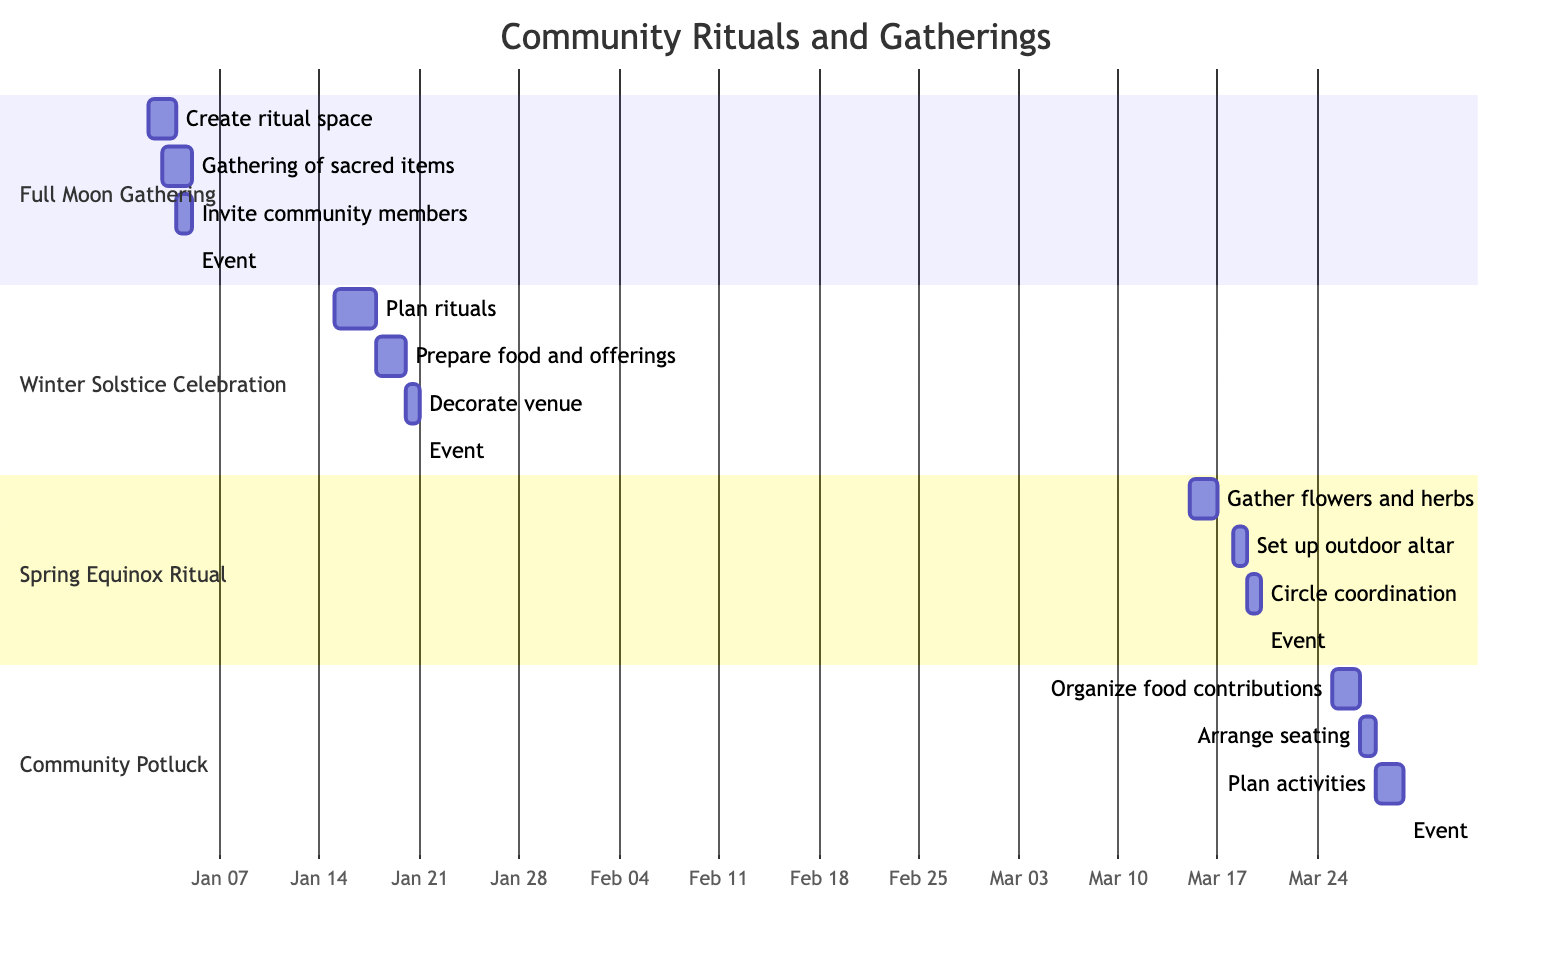What is the date of the Full Moon Gathering? The Gantt chart lists the Full Moon Gathering under the section title, and the associated date next to it is January 5, 2024.
Answer: January 5, 2024 What are the themes for the Winter Solstice Celebration? The Gantt chart specifies the theme for each event in the description, and for the Winter Solstice Celebration, the listed theme is "Renewal and Hope."
Answer: Renewal and Hope How many preparation tasks are planned for the Community Potluck and Sharing? By examining the section for Community Potluck, there are three preparation tasks listed: "Organize food contributions," "Arrange seating," and "Plan activities." Counting these gives a total of three tasks.
Answer: 3 What participant role is listed for the Full Moon Gathering? The Gantt chart indicates participant roles for each event. For the Full Moon Gathering, the roles include "Facilitator," "Ceremony Leader," and "Musician." Taking the first one listed indicates that one participant role is "Facilitator."
Answer: Facilitator Which event has the preparation task "Gather flowers and herbs"? Looking at the section for the Spring Equinox Ritual, the task "Gather flowers and herbs" is specified. This indicates it is related to that event.
Answer: Spring Equinox Ritual What is the last task before the Winter Solstice Celebration? The timeline shows that the last preparation task listed before the Winter Solstice Celebration event milestone is "Decorate venue," scheduled for January 20, 2024.
Answer: Decorate venue Which event follows the Full Moon Gathering in the timeline? In the Gantt chart timeline, the Full Moon Gathering is on January 5, 2024, and the next event listed after that, based on the date, is the Winter Solstice Celebration on January 21, 2024.
Answer: Winter Solstice Celebration What is the duration of the preparation for the Spring Equinox Ritual? The tasks for the Spring Equinox Ritual start on March 15, 2024, and the last task is completed on March 19, 2024. This makes the total duration of preparation from March 15 to March 19 equal to 5 days.
Answer: 5 days How many participants are involved in the Spring Equinox Ritual? The Spring Equinox Ritual section lists three participant roles: "Altar Keeper," "Guide," and "Participant." This indicates that there are three roles involved.
Answer: 3 